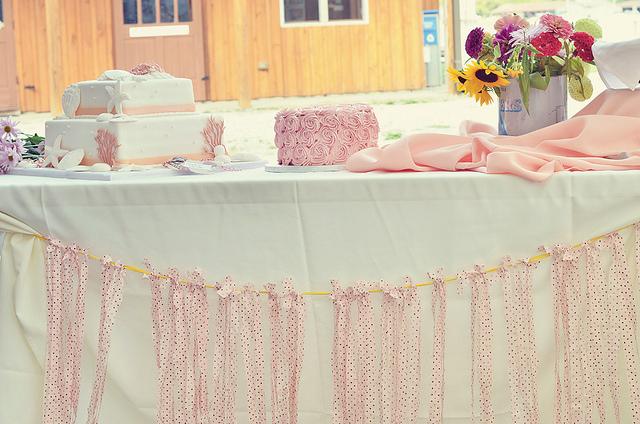How many cakes are there?
Concise answer only. 2. What shape is the cake?
Short answer required. Square. What kind of cake is the one on the left?
Be succinct. Wedding. 